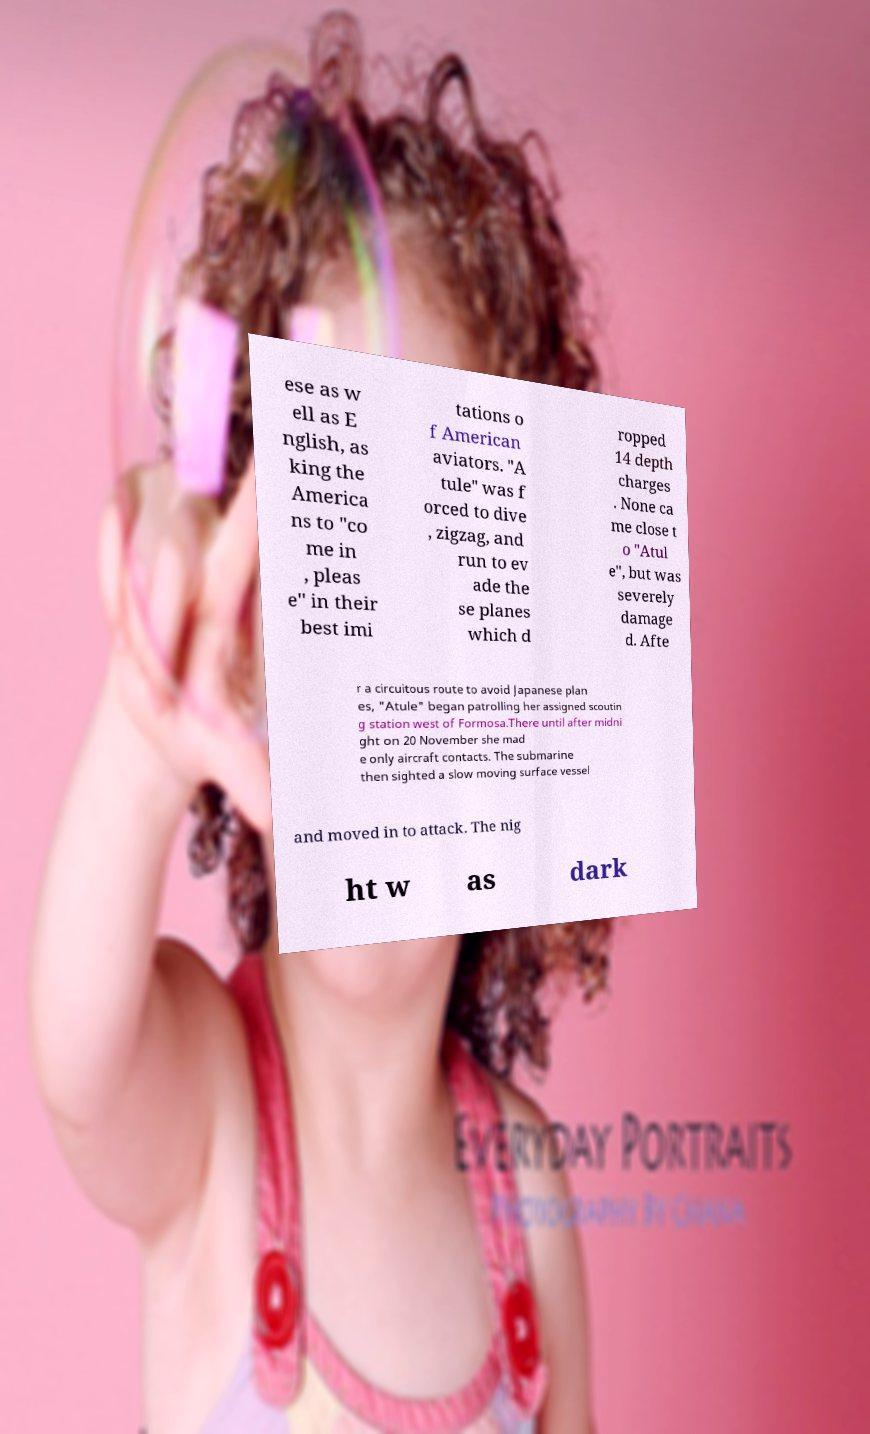I need the written content from this picture converted into text. Can you do that? ese as w ell as E nglish, as king the America ns to "co me in , pleas e" in their best imi tations o f American aviators. "A tule" was f orced to dive , zigzag, and run to ev ade the se planes which d ropped 14 depth charges . None ca me close t o "Atul e", but was severely damage d. Afte r a circuitous route to avoid Japanese plan es, "Atule" began patrolling her assigned scoutin g station west of Formosa.There until after midni ght on 20 November she mad e only aircraft contacts. The submarine then sighted a slow moving surface vessel and moved in to attack. The nig ht w as dark 